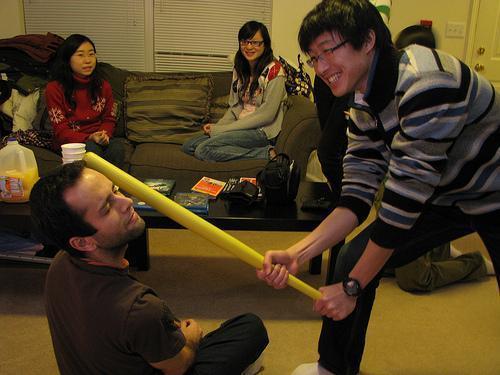How many people are in the picture?
Give a very brief answer. 5. How many people are holding stick?
Give a very brief answer. 0. 